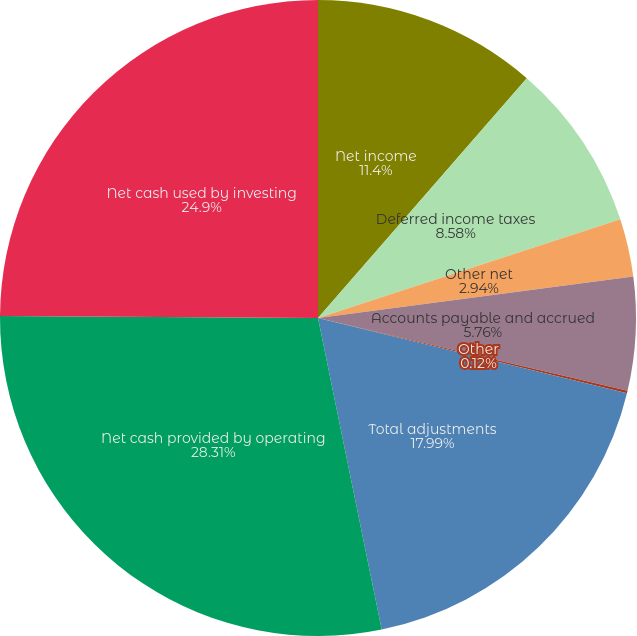<chart> <loc_0><loc_0><loc_500><loc_500><pie_chart><fcel>Net income<fcel>Deferred income taxes<fcel>Other net<fcel>Accounts payable and accrued<fcel>Other<fcel>Total adjustments<fcel>Net cash provided by operating<fcel>Net cash used by investing<nl><fcel>11.4%<fcel>8.58%<fcel>2.94%<fcel>5.76%<fcel>0.12%<fcel>17.99%<fcel>28.31%<fcel>24.9%<nl></chart> 